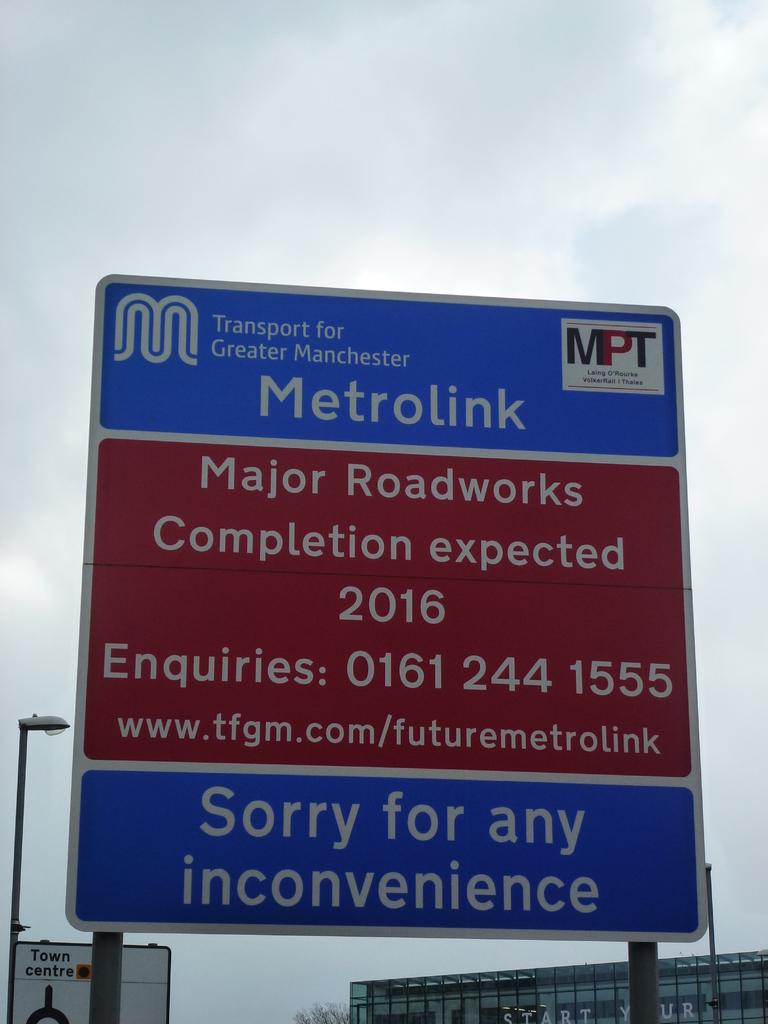<image>
Present a compact description of the photo's key features. Blue and red sign which says Metrolink on it. 